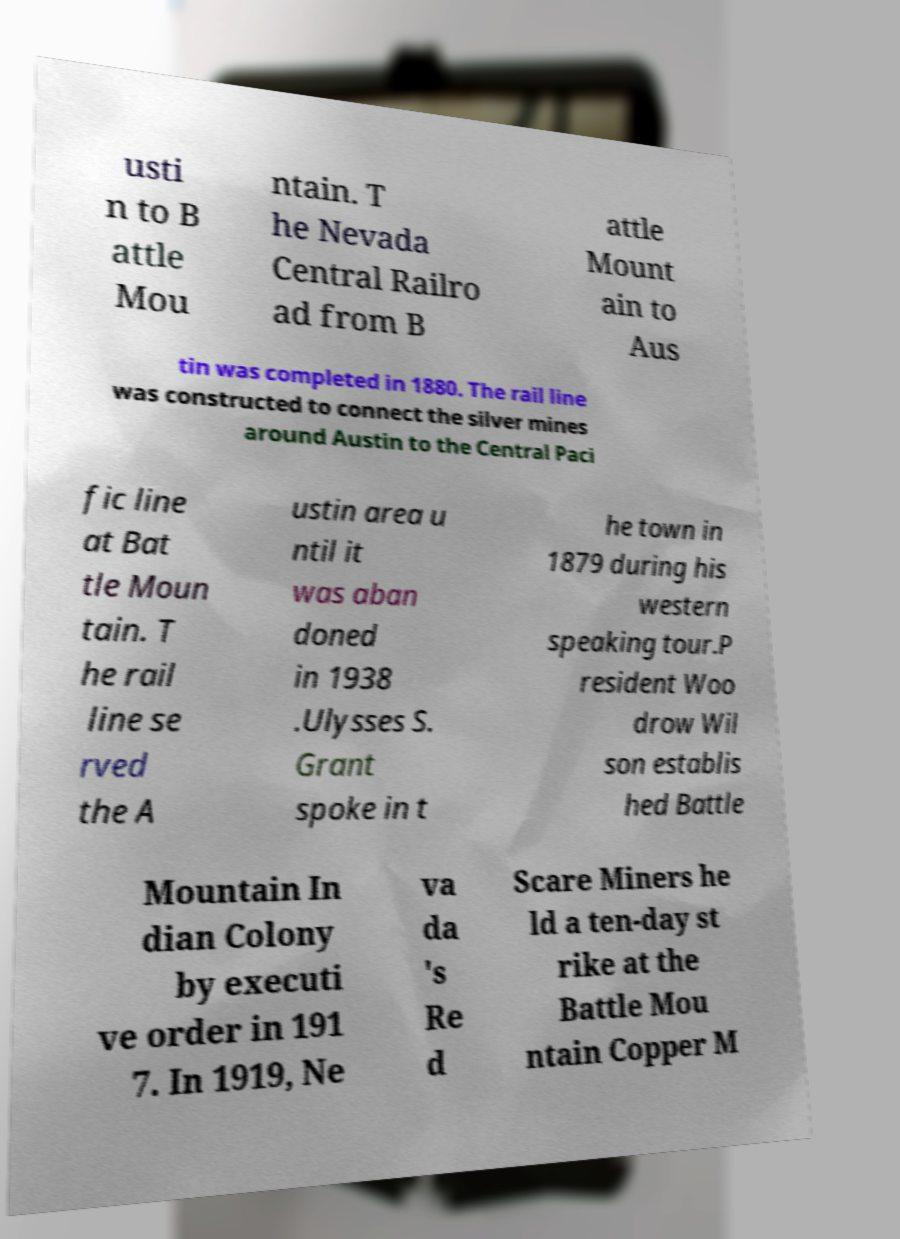I need the written content from this picture converted into text. Can you do that? usti n to B attle Mou ntain. T he Nevada Central Railro ad from B attle Mount ain to Aus tin was completed in 1880. The rail line was constructed to connect the silver mines around Austin to the Central Paci fic line at Bat tle Moun tain. T he rail line se rved the A ustin area u ntil it was aban doned in 1938 .Ulysses S. Grant spoke in t he town in 1879 during his western speaking tour.P resident Woo drow Wil son establis hed Battle Mountain In dian Colony by executi ve order in 191 7. In 1919, Ne va da 's Re d Scare Miners he ld a ten-day st rike at the Battle Mou ntain Copper M 